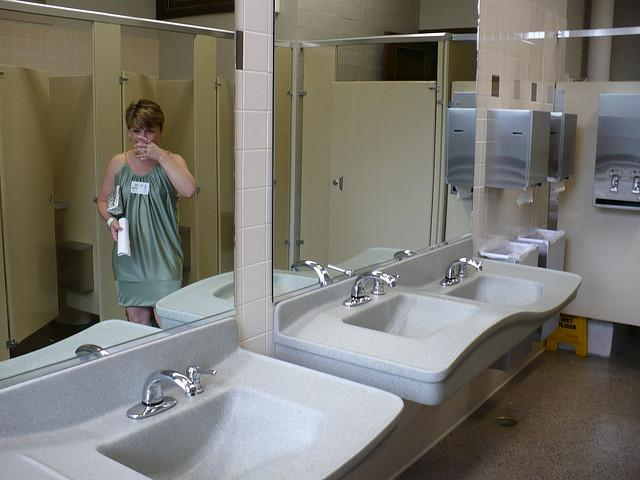What is the woman wearing? dress 